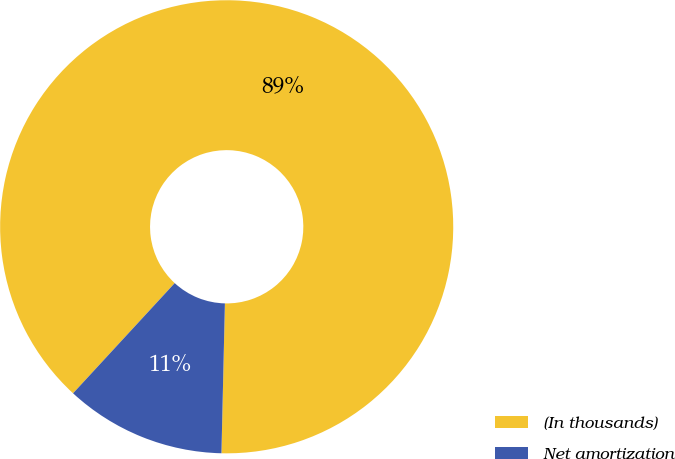<chart> <loc_0><loc_0><loc_500><loc_500><pie_chart><fcel>(In thousands)<fcel>Net amortization<nl><fcel>88.51%<fcel>11.49%<nl></chart> 